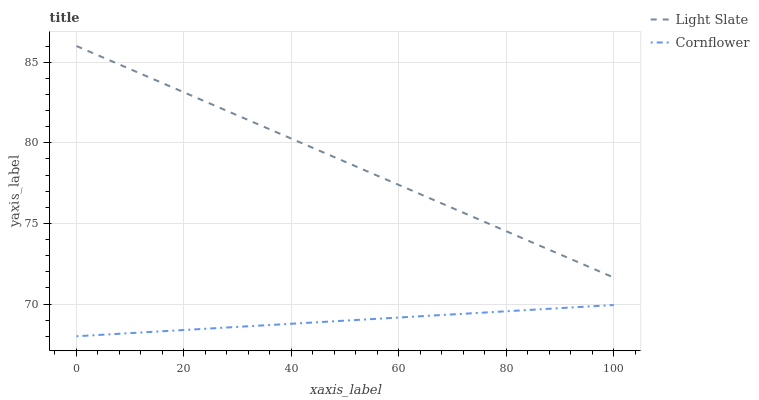Does Cornflower have the maximum area under the curve?
Answer yes or no. No. Is Cornflower the smoothest?
Answer yes or no. No. Does Cornflower have the highest value?
Answer yes or no. No. Is Cornflower less than Light Slate?
Answer yes or no. Yes. Is Light Slate greater than Cornflower?
Answer yes or no. Yes. Does Cornflower intersect Light Slate?
Answer yes or no. No. 